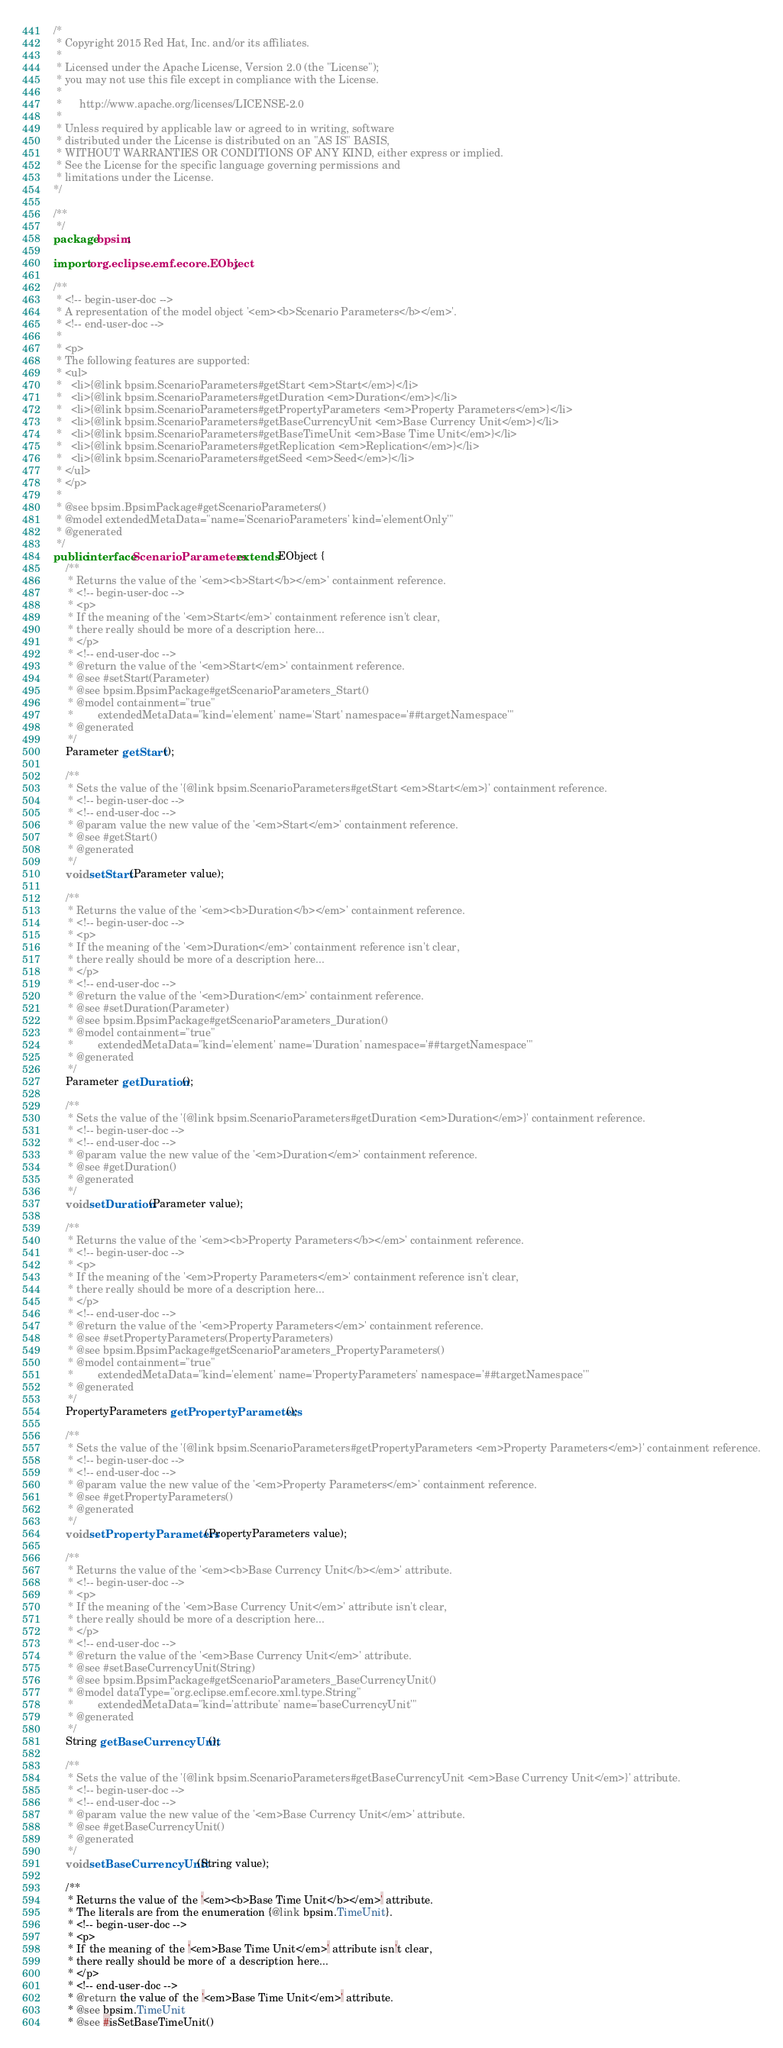<code> <loc_0><loc_0><loc_500><loc_500><_Java_>/*
 * Copyright 2015 Red Hat, Inc. and/or its affiliates.
 *
 * Licensed under the Apache License, Version 2.0 (the "License");
 * you may not use this file except in compliance with the License.
 * 
 *      http://www.apache.org/licenses/LICENSE-2.0
 *
 * Unless required by applicable law or agreed to in writing, software
 * distributed under the License is distributed on an "AS IS" BASIS,
 * WITHOUT WARRANTIES OR CONDITIONS OF ANY KIND, either express or implied.
 * See the License for the specific language governing permissions and
 * limitations under the License.
*/

/**
 */
package bpsim;

import org.eclipse.emf.ecore.EObject;

/**
 * <!-- begin-user-doc -->
 * A representation of the model object '<em><b>Scenario Parameters</b></em>'.
 * <!-- end-user-doc -->
 *
 * <p>
 * The following features are supported:
 * <ul>
 *   <li>{@link bpsim.ScenarioParameters#getStart <em>Start</em>}</li>
 *   <li>{@link bpsim.ScenarioParameters#getDuration <em>Duration</em>}</li>
 *   <li>{@link bpsim.ScenarioParameters#getPropertyParameters <em>Property Parameters</em>}</li>
 *   <li>{@link bpsim.ScenarioParameters#getBaseCurrencyUnit <em>Base Currency Unit</em>}</li>
 *   <li>{@link bpsim.ScenarioParameters#getBaseTimeUnit <em>Base Time Unit</em>}</li>
 *   <li>{@link bpsim.ScenarioParameters#getReplication <em>Replication</em>}</li>
 *   <li>{@link bpsim.ScenarioParameters#getSeed <em>Seed</em>}</li>
 * </ul>
 * </p>
 *
 * @see bpsim.BpsimPackage#getScenarioParameters()
 * @model extendedMetaData="name='ScenarioParameters' kind='elementOnly'"
 * @generated
 */
public interface ScenarioParameters extends EObject {
	/**
	 * Returns the value of the '<em><b>Start</b></em>' containment reference.
	 * <!-- begin-user-doc -->
	 * <p>
	 * If the meaning of the '<em>Start</em>' containment reference isn't clear,
	 * there really should be more of a description here...
	 * </p>
	 * <!-- end-user-doc -->
	 * @return the value of the '<em>Start</em>' containment reference.
	 * @see #setStart(Parameter)
	 * @see bpsim.BpsimPackage#getScenarioParameters_Start()
	 * @model containment="true"
	 *        extendedMetaData="kind='element' name='Start' namespace='##targetNamespace'"
	 * @generated
	 */
	Parameter getStart();

	/**
	 * Sets the value of the '{@link bpsim.ScenarioParameters#getStart <em>Start</em>}' containment reference.
	 * <!-- begin-user-doc -->
	 * <!-- end-user-doc -->
	 * @param value the new value of the '<em>Start</em>' containment reference.
	 * @see #getStart()
	 * @generated
	 */
	void setStart(Parameter value);

	/**
	 * Returns the value of the '<em><b>Duration</b></em>' containment reference.
	 * <!-- begin-user-doc -->
	 * <p>
	 * If the meaning of the '<em>Duration</em>' containment reference isn't clear,
	 * there really should be more of a description here...
	 * </p>
	 * <!-- end-user-doc -->
	 * @return the value of the '<em>Duration</em>' containment reference.
	 * @see #setDuration(Parameter)
	 * @see bpsim.BpsimPackage#getScenarioParameters_Duration()
	 * @model containment="true"
	 *        extendedMetaData="kind='element' name='Duration' namespace='##targetNamespace'"
	 * @generated
	 */
	Parameter getDuration();

	/**
	 * Sets the value of the '{@link bpsim.ScenarioParameters#getDuration <em>Duration</em>}' containment reference.
	 * <!-- begin-user-doc -->
	 * <!-- end-user-doc -->
	 * @param value the new value of the '<em>Duration</em>' containment reference.
	 * @see #getDuration()
	 * @generated
	 */
	void setDuration(Parameter value);

	/**
	 * Returns the value of the '<em><b>Property Parameters</b></em>' containment reference.
	 * <!-- begin-user-doc -->
	 * <p>
	 * If the meaning of the '<em>Property Parameters</em>' containment reference isn't clear,
	 * there really should be more of a description here...
	 * </p>
	 * <!-- end-user-doc -->
	 * @return the value of the '<em>Property Parameters</em>' containment reference.
	 * @see #setPropertyParameters(PropertyParameters)
	 * @see bpsim.BpsimPackage#getScenarioParameters_PropertyParameters()
	 * @model containment="true"
	 *        extendedMetaData="kind='element' name='PropertyParameters' namespace='##targetNamespace'"
	 * @generated
	 */
	PropertyParameters getPropertyParameters();

	/**
	 * Sets the value of the '{@link bpsim.ScenarioParameters#getPropertyParameters <em>Property Parameters</em>}' containment reference.
	 * <!-- begin-user-doc -->
	 * <!-- end-user-doc -->
	 * @param value the new value of the '<em>Property Parameters</em>' containment reference.
	 * @see #getPropertyParameters()
	 * @generated
	 */
	void setPropertyParameters(PropertyParameters value);

	/**
	 * Returns the value of the '<em><b>Base Currency Unit</b></em>' attribute.
	 * <!-- begin-user-doc -->
	 * <p>
	 * If the meaning of the '<em>Base Currency Unit</em>' attribute isn't clear,
	 * there really should be more of a description here...
	 * </p>
	 * <!-- end-user-doc -->
	 * @return the value of the '<em>Base Currency Unit</em>' attribute.
	 * @see #setBaseCurrencyUnit(String)
	 * @see bpsim.BpsimPackage#getScenarioParameters_BaseCurrencyUnit()
	 * @model dataType="org.eclipse.emf.ecore.xml.type.String"
	 *        extendedMetaData="kind='attribute' name='baseCurrencyUnit'"
	 * @generated
	 */
	String getBaseCurrencyUnit();

	/**
	 * Sets the value of the '{@link bpsim.ScenarioParameters#getBaseCurrencyUnit <em>Base Currency Unit</em>}' attribute.
	 * <!-- begin-user-doc -->
	 * <!-- end-user-doc -->
	 * @param value the new value of the '<em>Base Currency Unit</em>' attribute.
	 * @see #getBaseCurrencyUnit()
	 * @generated
	 */
	void setBaseCurrencyUnit(String value);

	/**
	 * Returns the value of the '<em><b>Base Time Unit</b></em>' attribute.
	 * The literals are from the enumeration {@link bpsim.TimeUnit}.
	 * <!-- begin-user-doc -->
	 * <p>
	 * If the meaning of the '<em>Base Time Unit</em>' attribute isn't clear,
	 * there really should be more of a description here...
	 * </p>
	 * <!-- end-user-doc -->
	 * @return the value of the '<em>Base Time Unit</em>' attribute.
	 * @see bpsim.TimeUnit
	 * @see #isSetBaseTimeUnit()</code> 